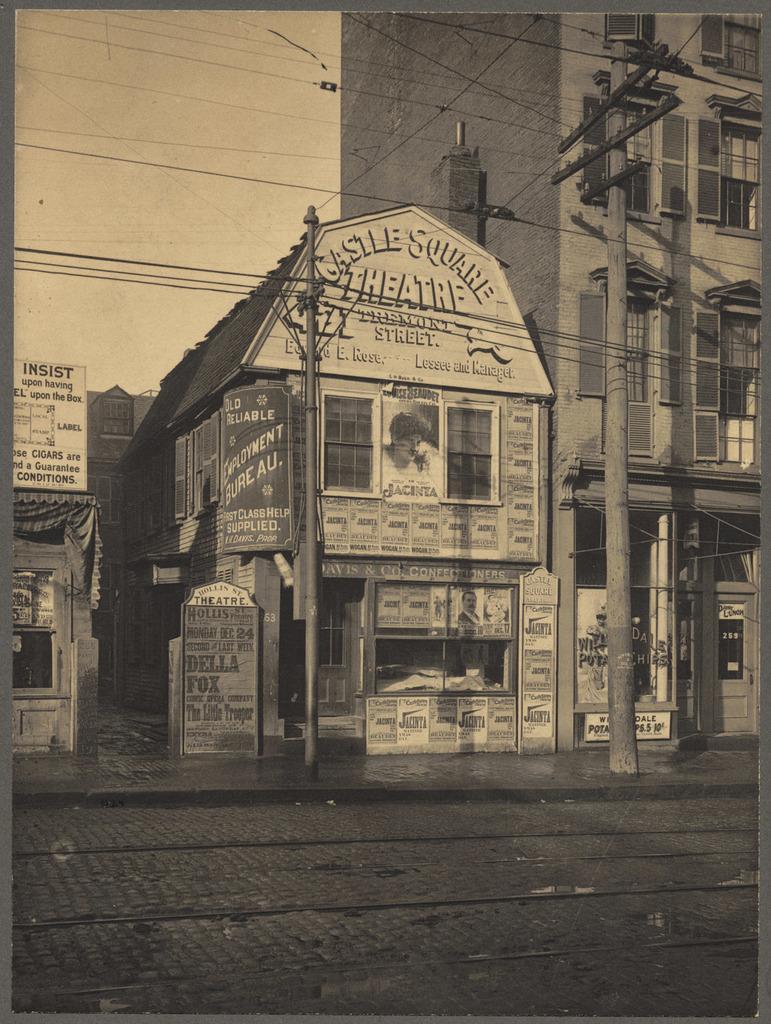Please provide a concise description of this image. This is a black and white image. In this image there is a road. Also there are electric poles with wires. In the back there are buildings with windows. Also there are posters on the building. In the background there is sky. 